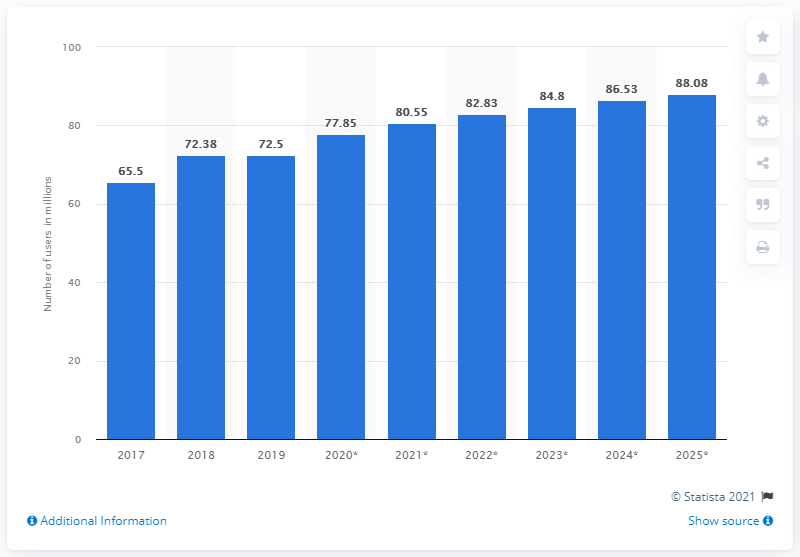Draw attention to some important aspects in this diagram. From 2017 to 2019, the year with the least number of Facebook users in the Philippines was 2017. By 2025, it is projected that there will be 88.08 Facebook users in the Philippines. From 2017 to 2019, the median number of Facebook users in the Philippines was consistently high, with the highest number of users being recorded in 2019. 